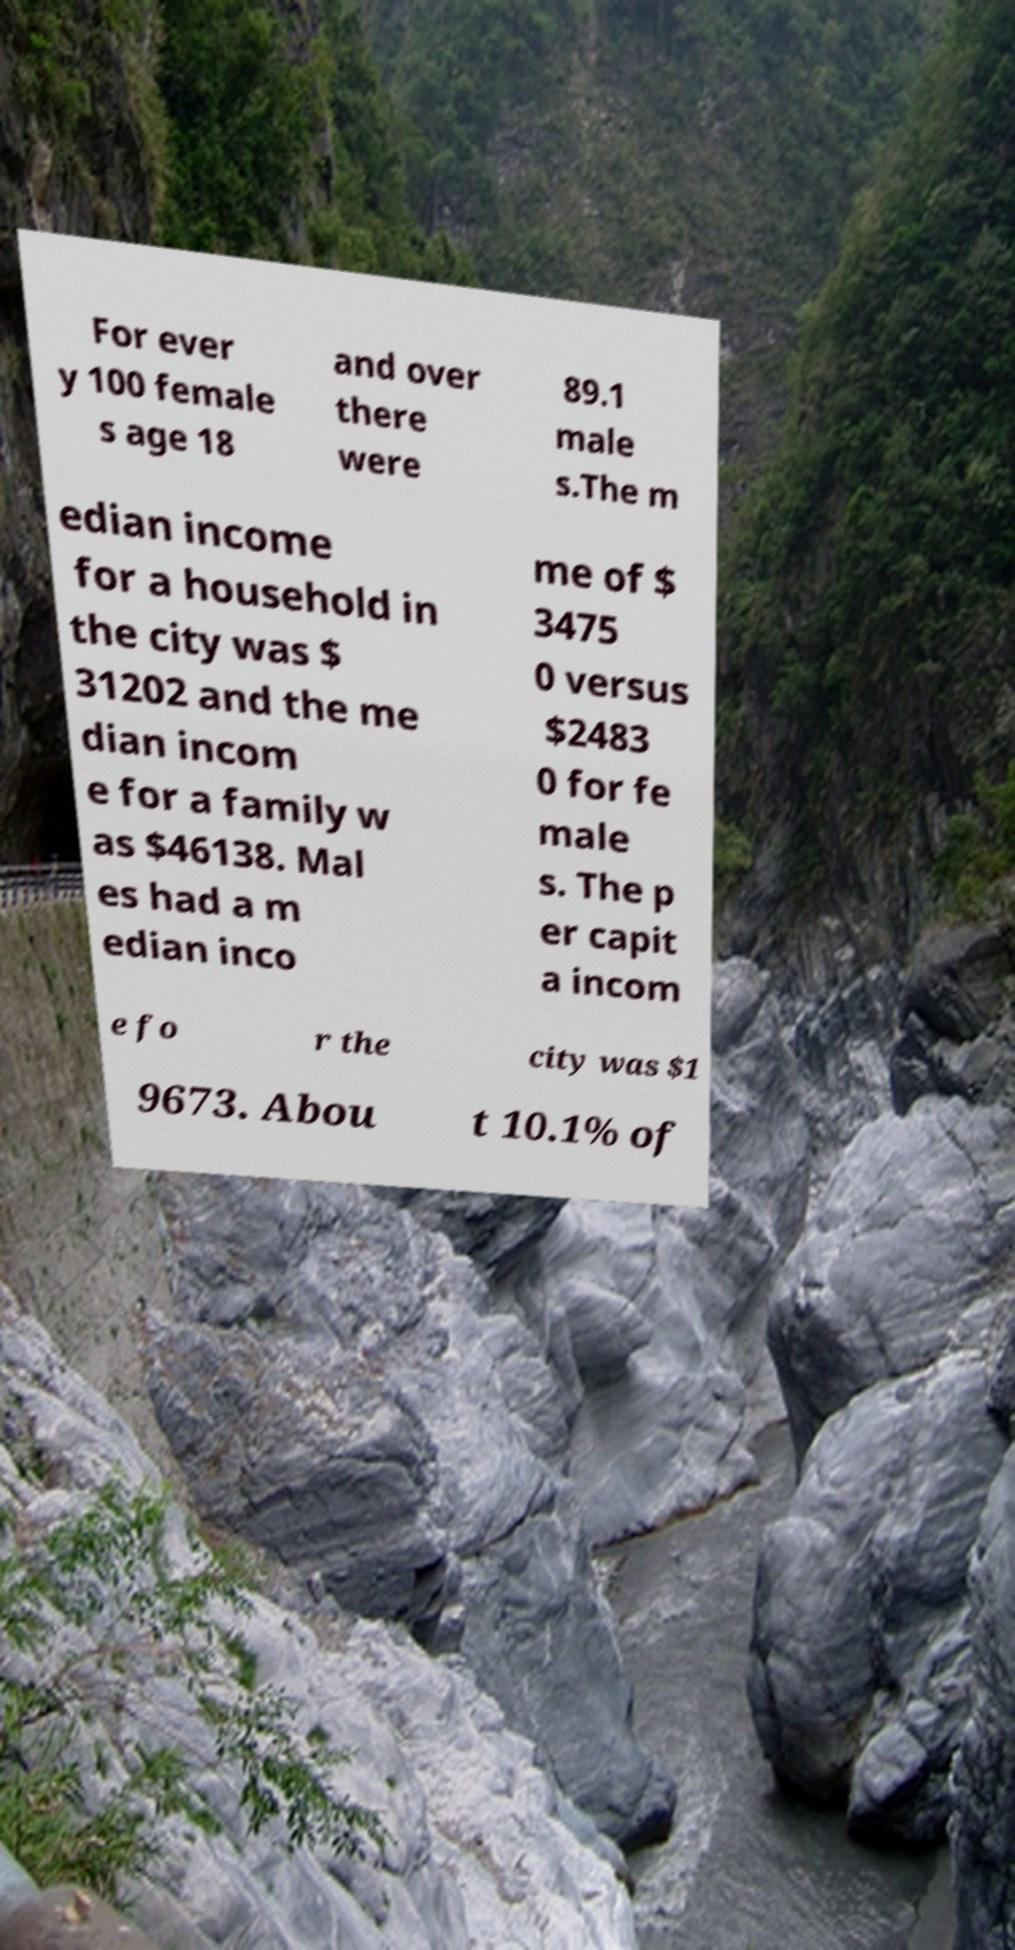Please identify and transcribe the text found in this image. For ever y 100 female s age 18 and over there were 89.1 male s.The m edian income for a household in the city was $ 31202 and the me dian incom e for a family w as $46138. Mal es had a m edian inco me of $ 3475 0 versus $2483 0 for fe male s. The p er capit a incom e fo r the city was $1 9673. Abou t 10.1% of 